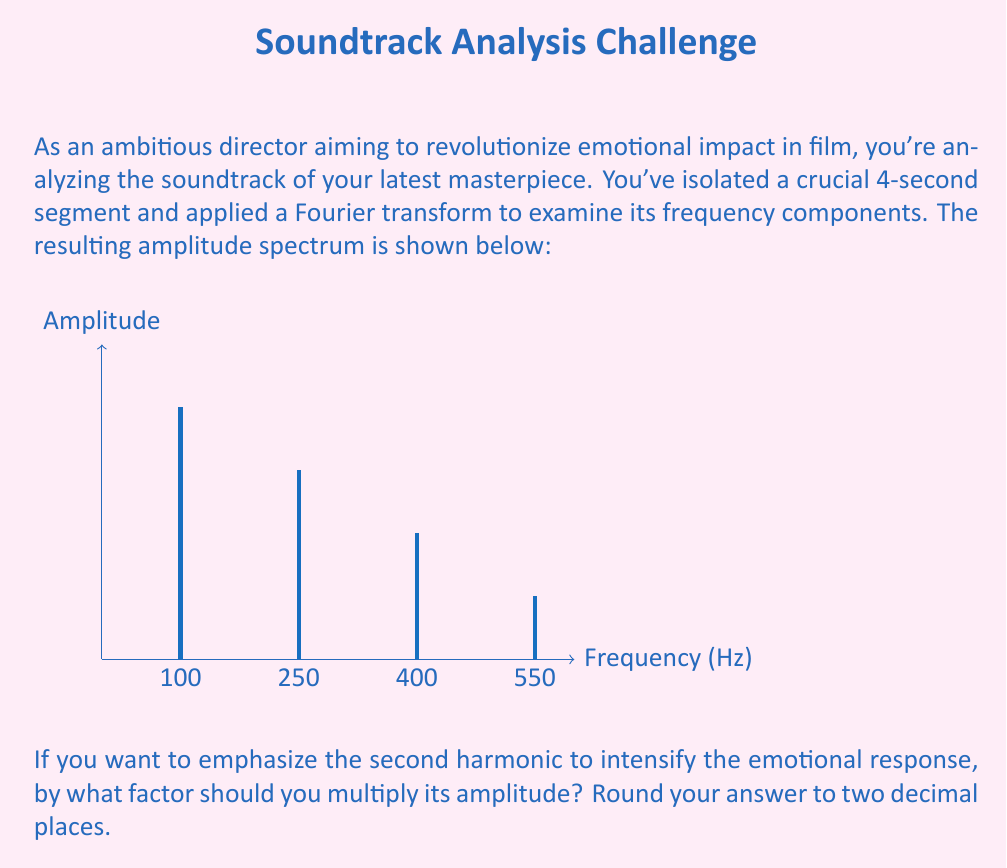What is the answer to this math problem? Let's approach this step-by-step:

1) First, we need to identify the fundamental frequency and its harmonics. The fundamental frequency is the lowest non-zero frequency in the spectrum, which is 100 Hz.

2) The harmonics are integer multiples of the fundamental frequency:
   - 1st harmonic (fundamental): 100 Hz
   - 2nd harmonic: 200 Hz
   - 3rd harmonic: 300 Hz
   - 4th harmonic: 400 Hz

3) We're interested in emphasizing the 2nd harmonic (250 Hz). Its current amplitude is 0.6.

4) To determine how much to amplify this frequency, we need to compare it to the fundamental frequency's amplitude, which is 0.8.

5) The ratio we're looking for is:

   $$\text{Amplification factor} = \frac{\text{Desired amplitude}}{\text{Current amplitude}}$$

6) We want the 2nd harmonic to have the same amplitude as the fundamental, so:

   $$\text{Amplification factor} = \frac{0.8}{0.6} = 1.3333...$$

7) Rounding to two decimal places gives us 1.33.
Answer: 1.33 